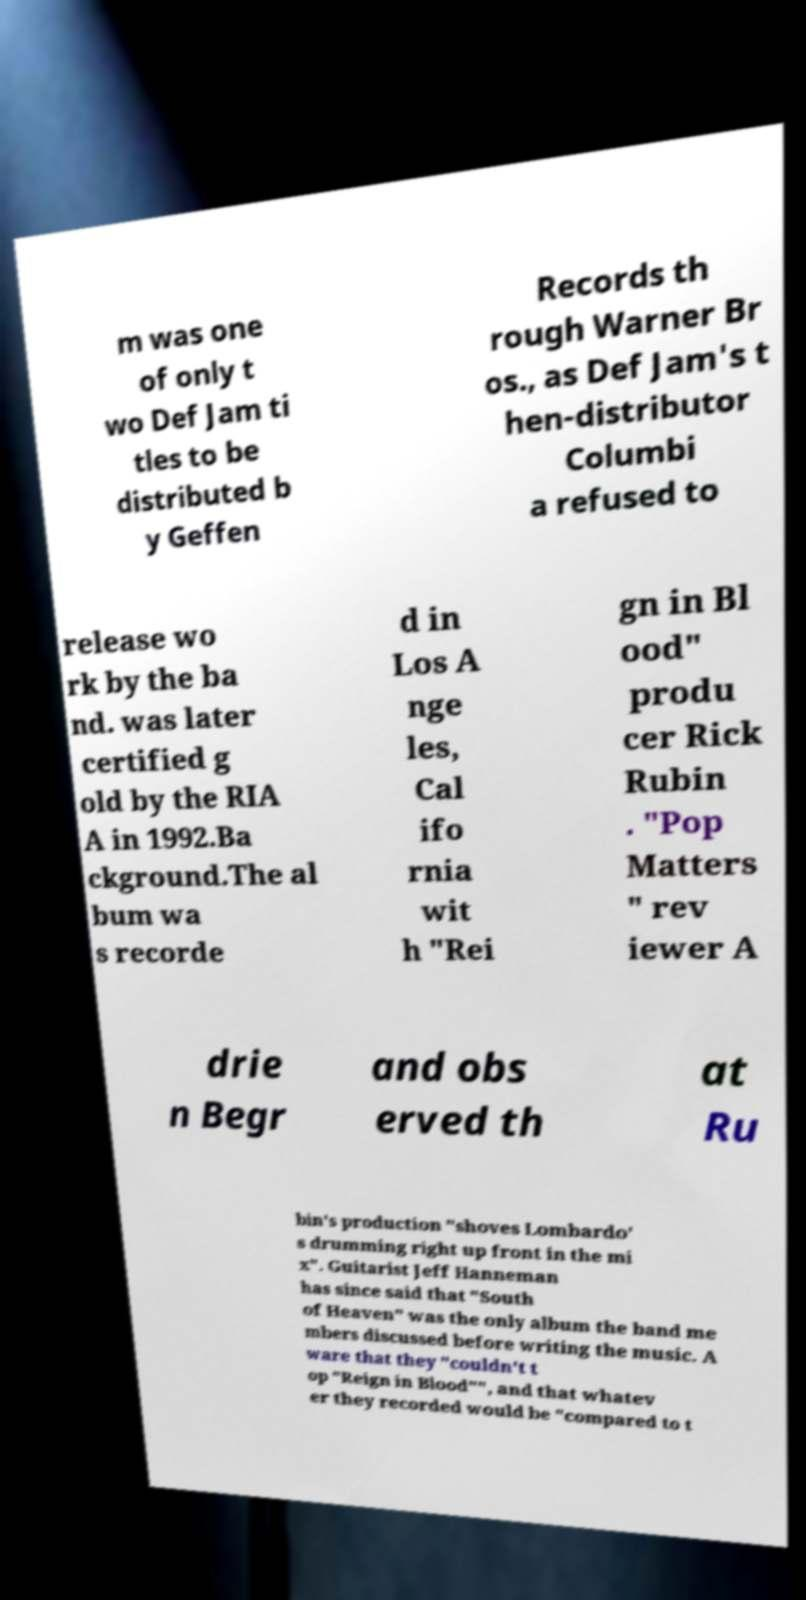Could you extract and type out the text from this image? m was one of only t wo Def Jam ti tles to be distributed b y Geffen Records th rough Warner Br os., as Def Jam's t hen-distributor Columbi a refused to release wo rk by the ba nd. was later certified g old by the RIA A in 1992.Ba ckground.The al bum wa s recorde d in Los A nge les, Cal ifo rnia wit h "Rei gn in Bl ood" produ cer Rick Rubin . "Pop Matters " rev iewer A drie n Begr and obs erved th at Ru bin's production "shoves Lombardo' s drumming right up front in the mi x". Guitarist Jeff Hanneman has since said that "South of Heaven" was the only album the band me mbers discussed before writing the music. A ware that they "couldn't t op "Reign in Blood"", and that whatev er they recorded would be "compared to t 